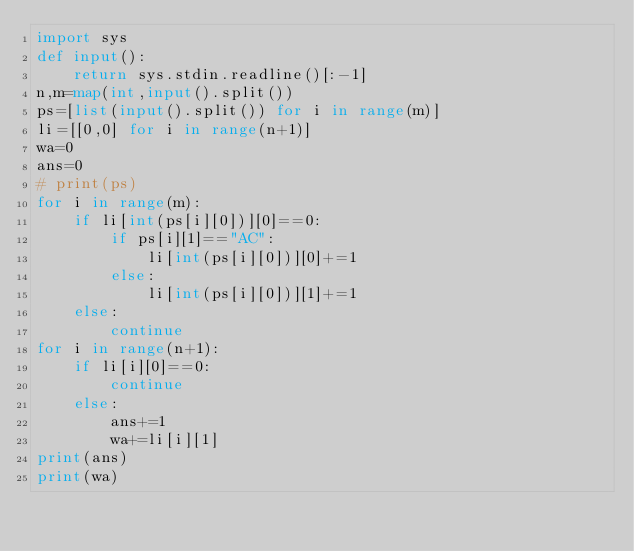<code> <loc_0><loc_0><loc_500><loc_500><_Python_>import sys
def input():
    return sys.stdin.readline()[:-1]
n,m=map(int,input().split())
ps=[list(input().split()) for i in range(m)]
li=[[0,0] for i in range(n+1)] 
wa=0
ans=0
# print(ps)
for i in range(m):
    if li[int(ps[i][0])][0]==0:
        if ps[i][1]=="AC":
            li[int(ps[i][0])][0]+=1
        else:
            li[int(ps[i][0])][1]+=1
    else:
        continue
for i in range(n+1):
    if li[i][0]==0:
        continue
    else:
        ans+=1
        wa+=li[i][1]
print(ans)
print(wa)</code> 